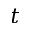<formula> <loc_0><loc_0><loc_500><loc_500>t</formula> 